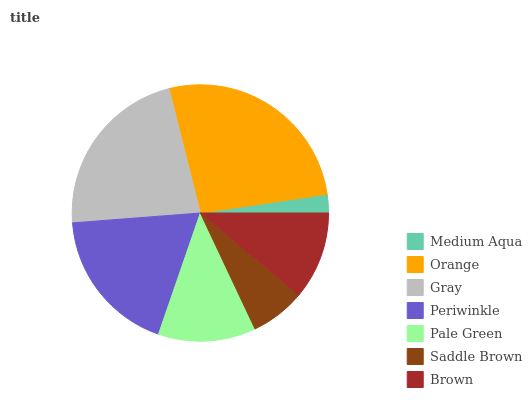Is Medium Aqua the minimum?
Answer yes or no. Yes. Is Orange the maximum?
Answer yes or no. Yes. Is Gray the minimum?
Answer yes or no. No. Is Gray the maximum?
Answer yes or no. No. Is Orange greater than Gray?
Answer yes or no. Yes. Is Gray less than Orange?
Answer yes or no. Yes. Is Gray greater than Orange?
Answer yes or no. No. Is Orange less than Gray?
Answer yes or no. No. Is Pale Green the high median?
Answer yes or no. Yes. Is Pale Green the low median?
Answer yes or no. Yes. Is Medium Aqua the high median?
Answer yes or no. No. Is Brown the low median?
Answer yes or no. No. 